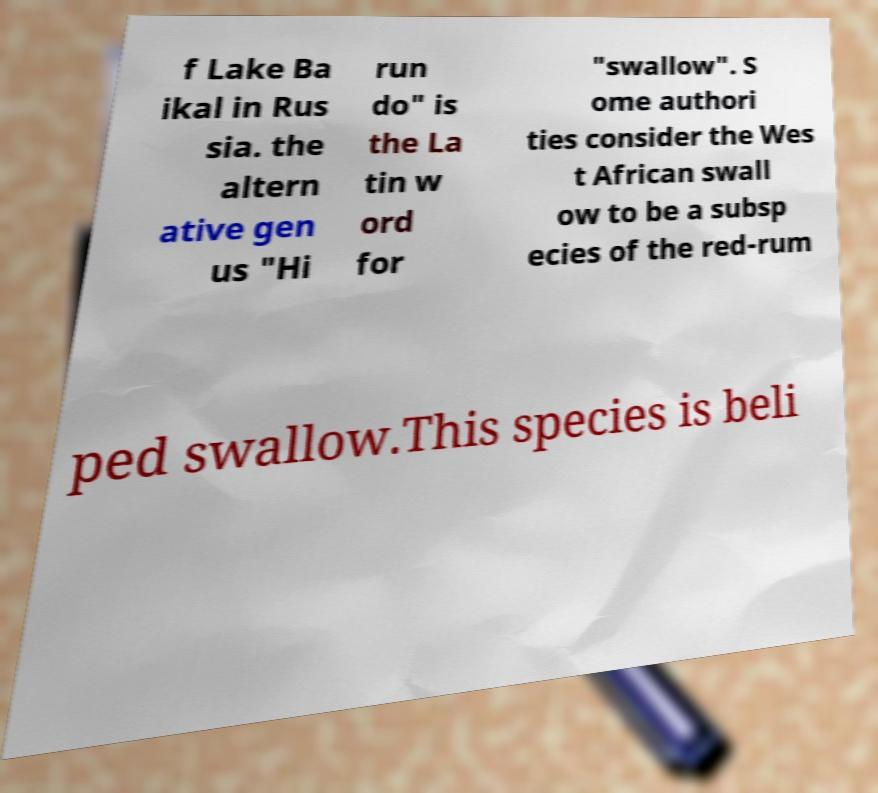There's text embedded in this image that I need extracted. Can you transcribe it verbatim? f Lake Ba ikal in Rus sia. the altern ative gen us "Hi run do" is the La tin w ord for "swallow". S ome authori ties consider the Wes t African swall ow to be a subsp ecies of the red-rum ped swallow.This species is beli 